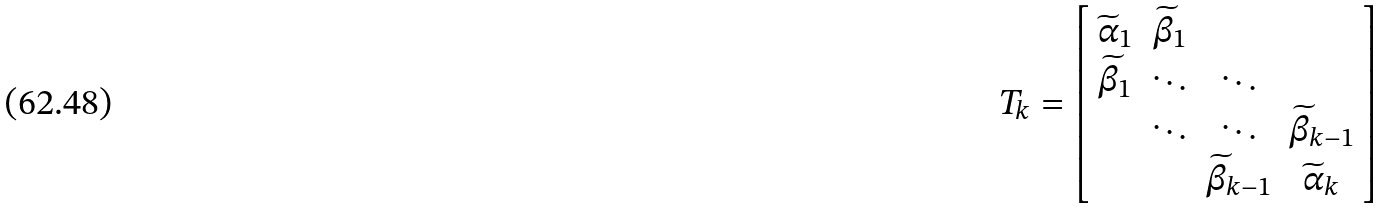<formula> <loc_0><loc_0><loc_500><loc_500>T _ { k } = \left [ \begin{array} { c c c c } \widetilde { \alpha } _ { 1 } & \widetilde { \beta } _ { 1 } \\ \widetilde { \beta } _ { 1 } & \ddots & \ddots \\ & \ddots & \ddots & \widetilde { \beta } _ { k - 1 } \\ & & \widetilde { \beta } _ { k - 1 } & \widetilde { \alpha } _ { k } \end{array} \right ]</formula> 